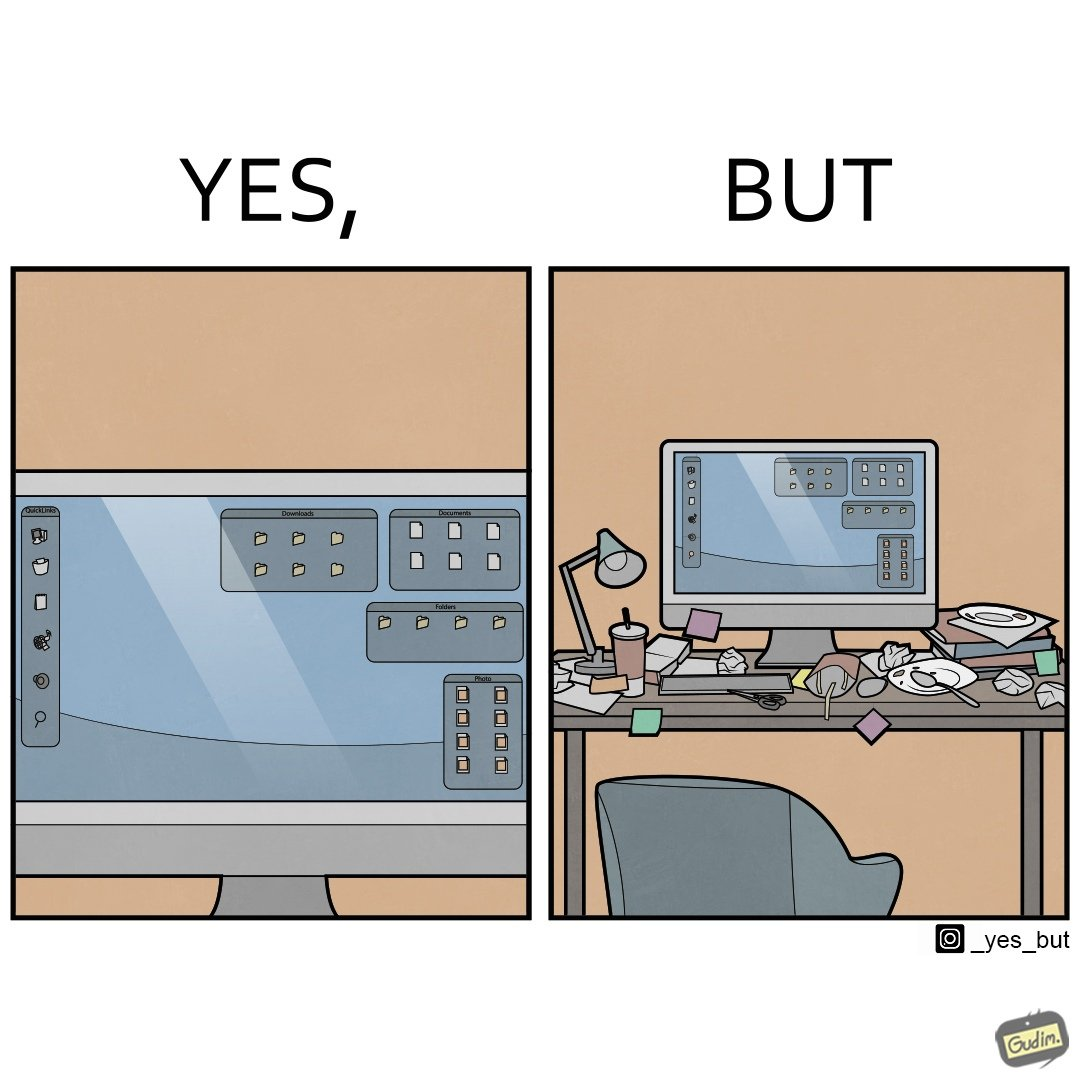Compare the left and right sides of this image. In the left part of the image: A desktop screen opened in a computer monitor. In the right part of the image: A desktop screen opened in a computer monitor on a table littered with used food packets, dirty plates, and wrappers 